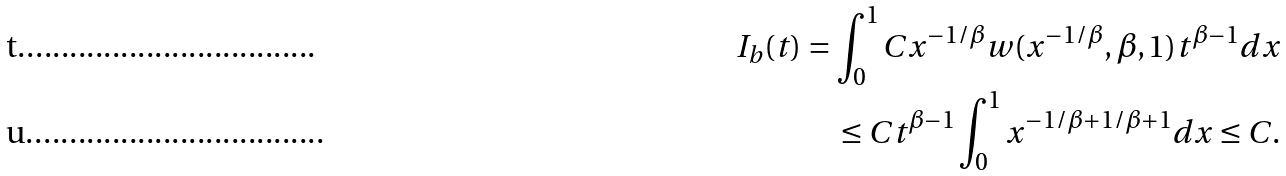Convert formula to latex. <formula><loc_0><loc_0><loc_500><loc_500>I _ { b } ( t ) = \int _ { 0 } ^ { 1 } C x ^ { - 1 / \beta } w ( x ^ { - 1 / \beta } , \beta , 1 ) t ^ { \beta - 1 } d x \\ \leq C t ^ { \beta - 1 } \int _ { 0 } ^ { 1 } x ^ { - 1 / \beta + 1 / \beta + 1 } d x \leq C .</formula> 